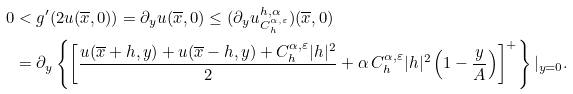<formula> <loc_0><loc_0><loc_500><loc_500>0 & < g ^ { \prime } ( 2 u ( \overline { x } , 0 ) ) = \partial _ { y } u ( \overline { x } , 0 ) \leq ( \partial _ { y } u ^ { h , \alpha } _ { C ^ { \alpha , \varepsilon } _ { h } } ) ( \overline { x } , 0 ) \\ & = \partial _ { y } \left \{ \left [ \frac { u ( \overline { x } + h , y ) + u ( \overline { x } - h , y ) + C ^ { \alpha , \varepsilon } _ { h } | h | ^ { 2 } } { 2 } + \alpha \, C ^ { \alpha , \varepsilon } _ { h } | h | ^ { 2 } \left ( 1 - \frac { y } { A } \right ) \right ] ^ { + } \right \} | _ { y = 0 } .</formula> 